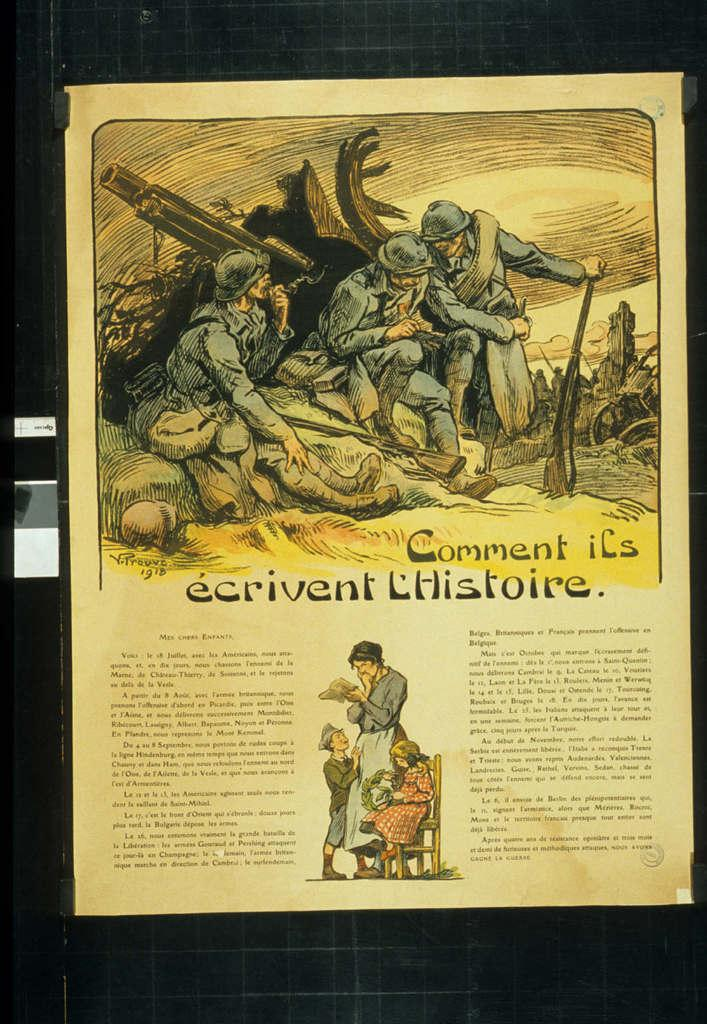What is present in the image that contains information? There is a paper in the image that contains text. What else can be found on the paper besides text? The paper contains pictures as well. How is the paper attached to the pin in the image? There is no pin present in the image, and the paper is not attached to anything. 